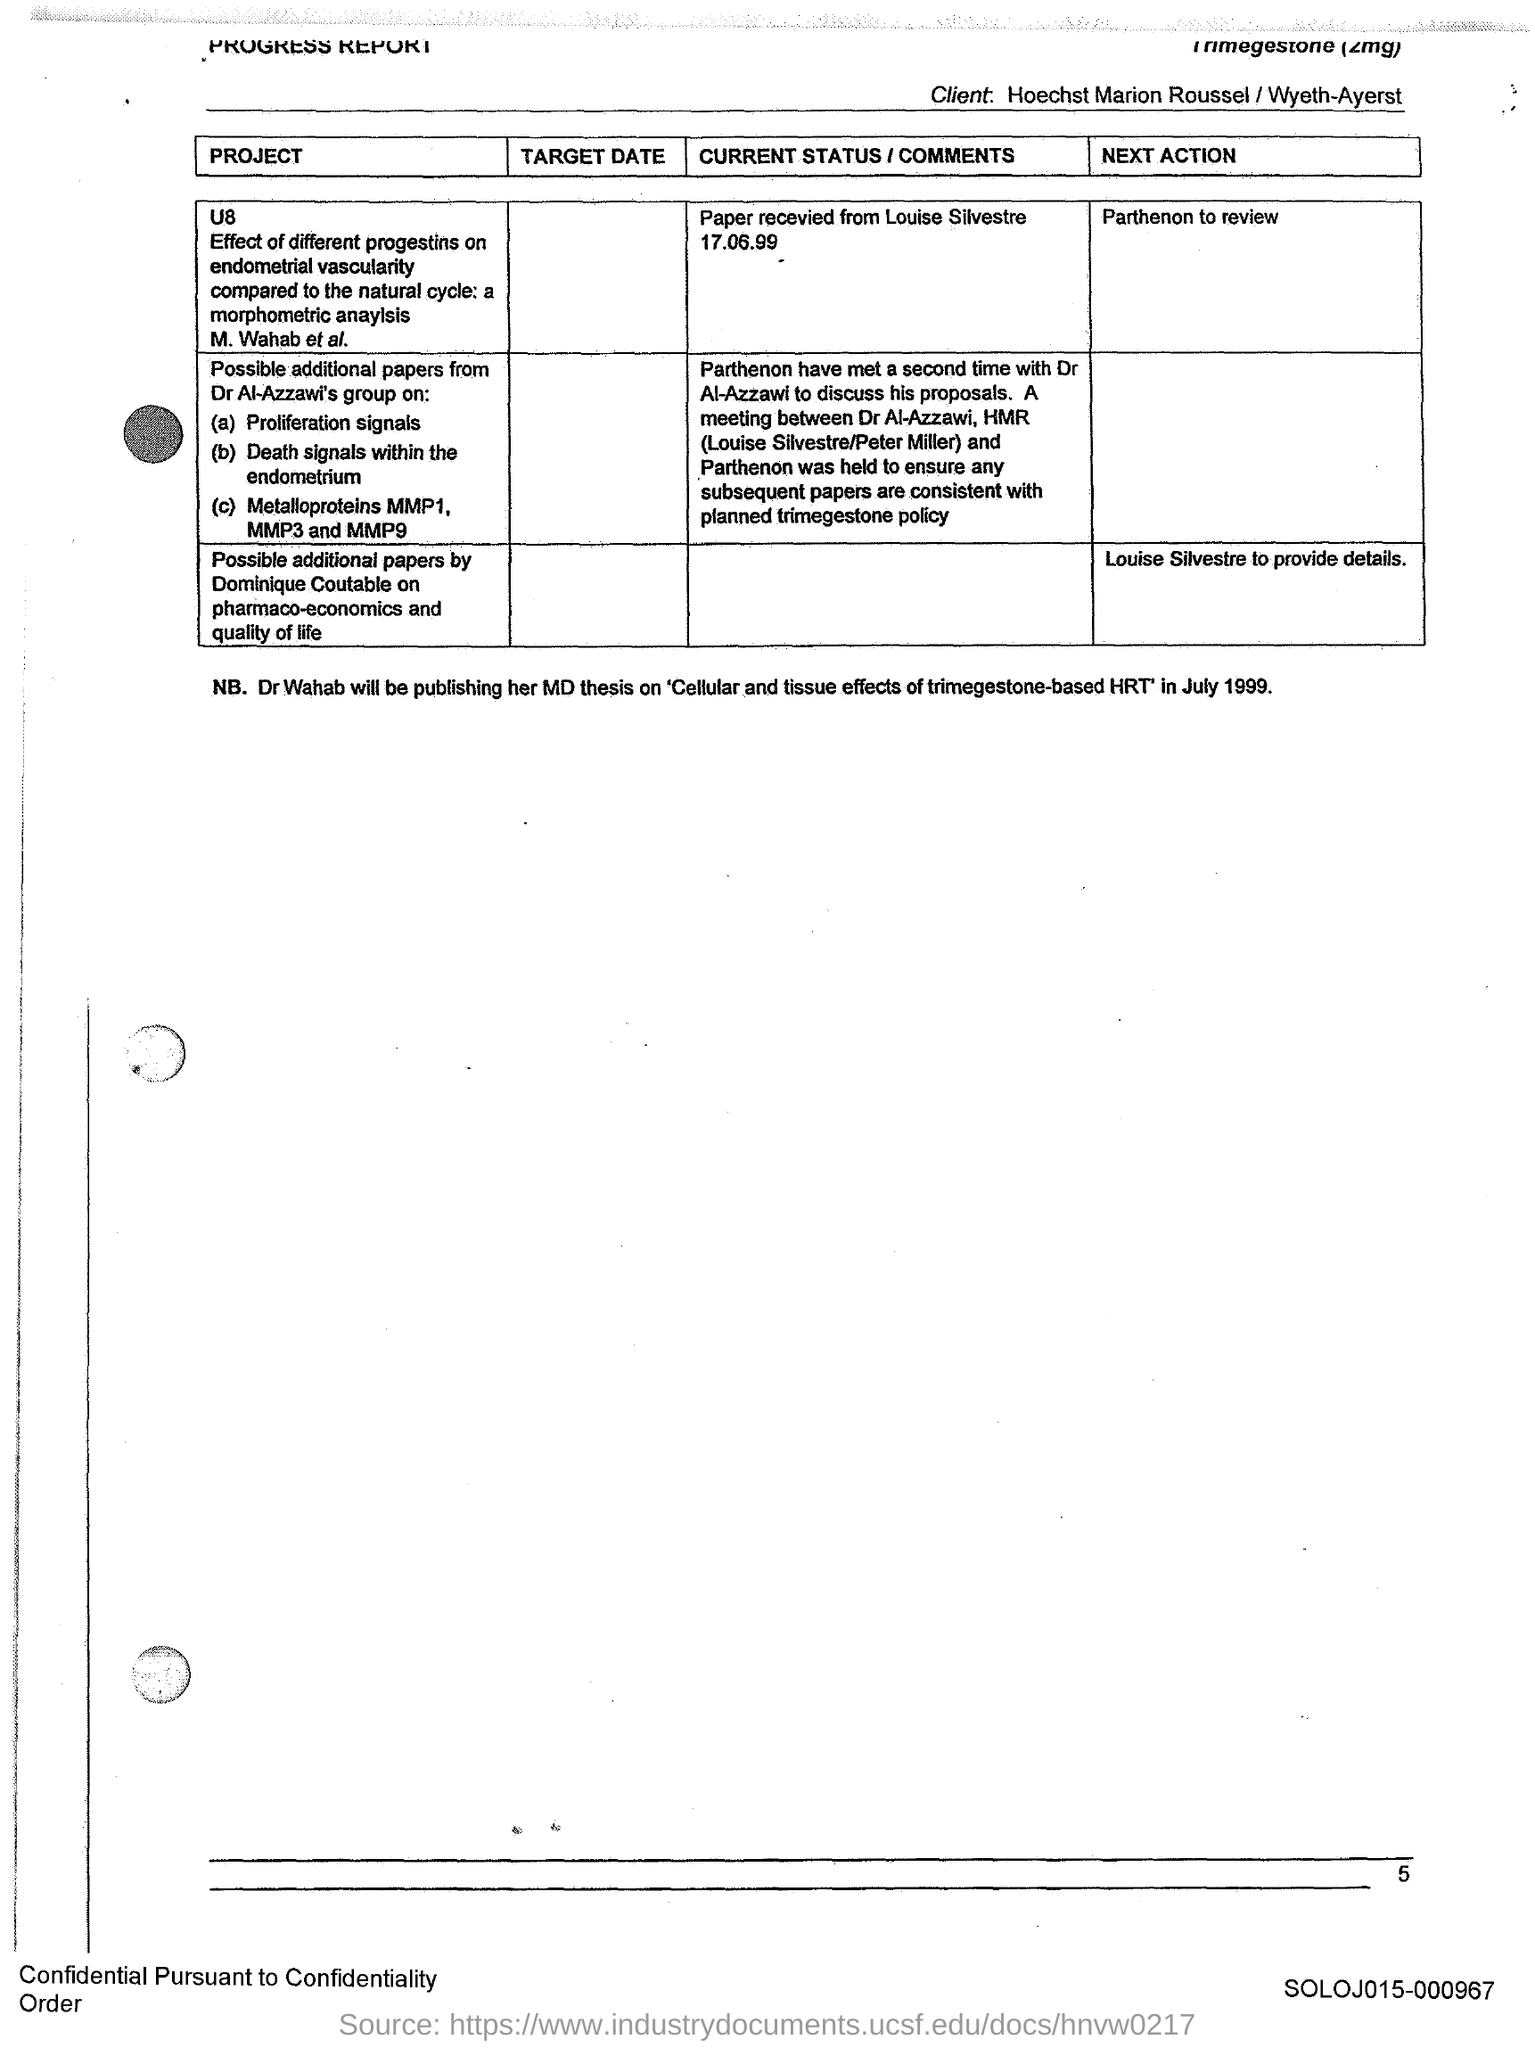Specify some key components in this picture. The page number is 5. 